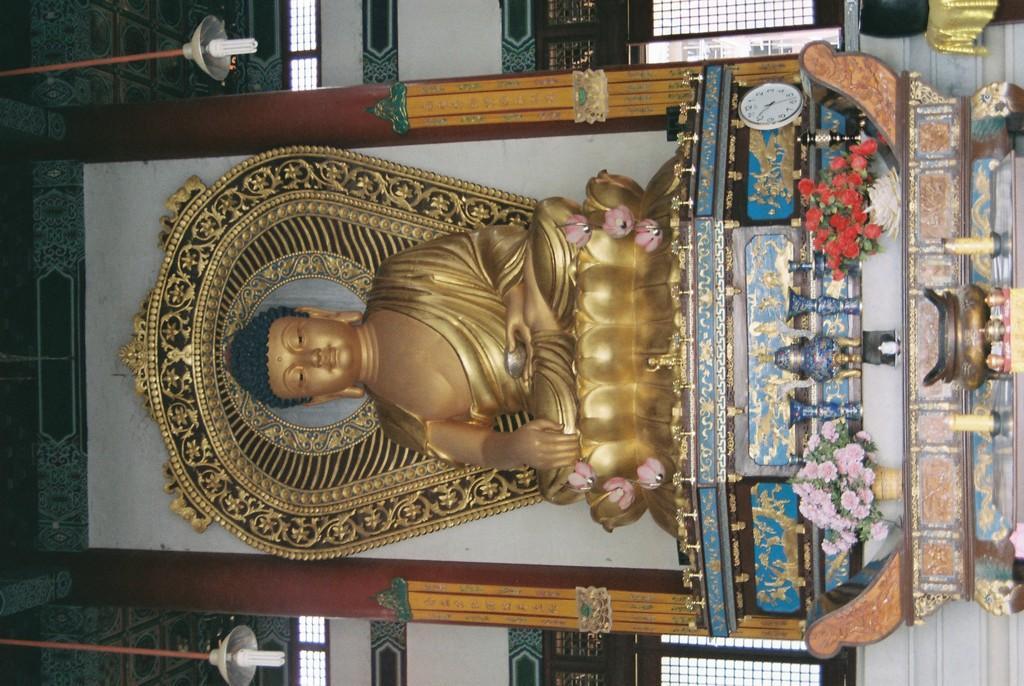Describe this image in one or two sentences. In the image there is a statue of buddha and under the statue there are flower vases and other objects. Around the statue there are windows. 